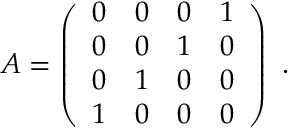<formula> <loc_0><loc_0><loc_500><loc_500>A = \left ( \begin{array} { l l l l } { 0 } & { 0 } & { 0 } & { 1 } \\ { 0 } & { 0 } & { 1 } & { 0 } \\ { 0 } & { 1 } & { 0 } & { 0 } \\ { 1 } & { 0 } & { 0 } & { 0 } \end{array} \right ) \ .</formula> 